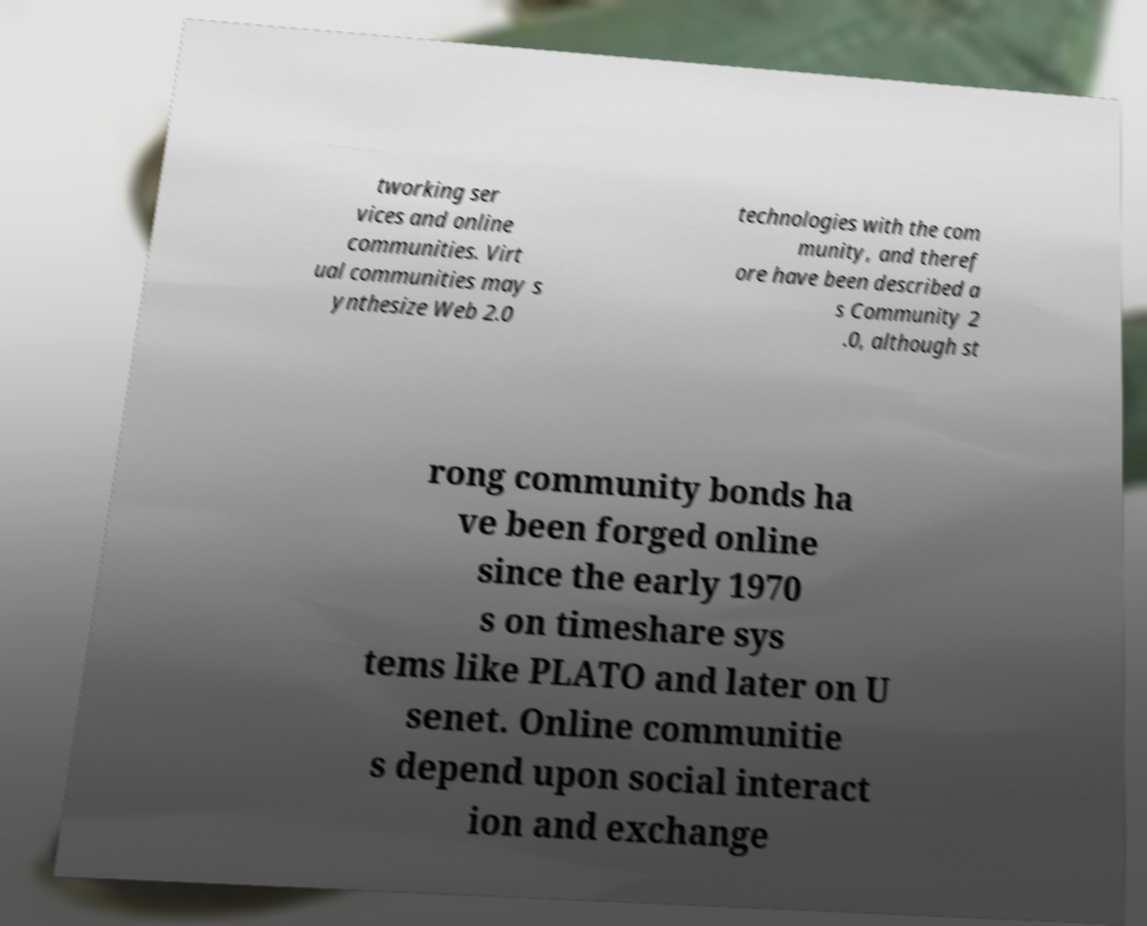What messages or text are displayed in this image? I need them in a readable, typed format. tworking ser vices and online communities. Virt ual communities may s ynthesize Web 2.0 technologies with the com munity, and theref ore have been described a s Community 2 .0, although st rong community bonds ha ve been forged online since the early 1970 s on timeshare sys tems like PLATO and later on U senet. Online communitie s depend upon social interact ion and exchange 